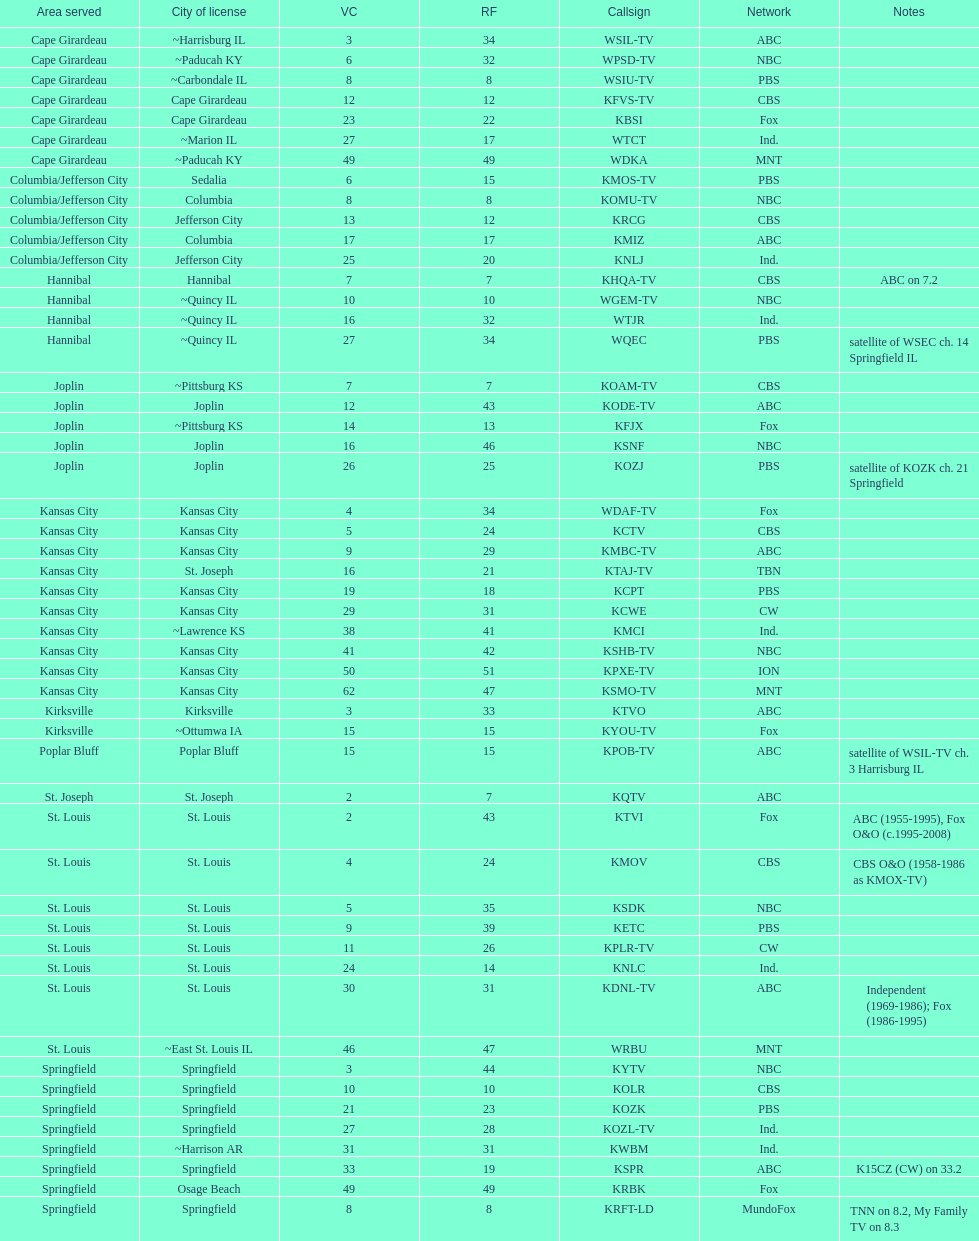Which station is licensed in the same city as koam-tv? KFJX. 